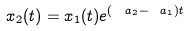<formula> <loc_0><loc_0><loc_500><loc_500>x _ { 2 } ( t ) = x _ { 1 } ( t ) e ^ { ( \ a _ { 2 } - \ a _ { 1 } ) t }</formula> 